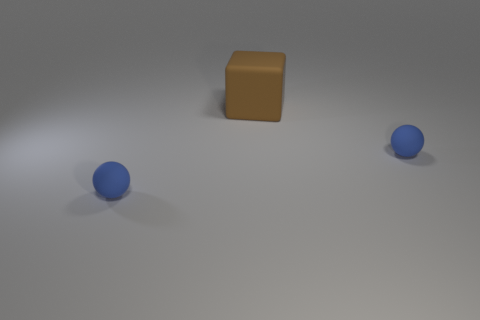There is a tiny ball on the right side of the large cube; is its color the same as the small matte ball that is left of the large brown matte block?
Your response must be concise. Yes. Are there any other things that have the same size as the brown rubber object?
Your answer should be very brief. No. What number of tiny balls are there?
Give a very brief answer. 2. Is there a blue thing that has the same size as the brown rubber block?
Your response must be concise. No. There is a tiny ball to the left of the large rubber cube; is there a large brown block to the left of it?
Give a very brief answer. No. There is a matte sphere that is to the left of the tiny thing that is to the right of the large block; what is its color?
Provide a short and direct response. Blue. Are there fewer big cubes than blue shiny balls?
Your answer should be compact. No. How many blue things are big rubber cubes or balls?
Make the answer very short. 2. Are there more large brown rubber objects than big gray cubes?
Give a very brief answer. Yes. How many other things are there of the same material as the brown cube?
Your answer should be compact. 2. 